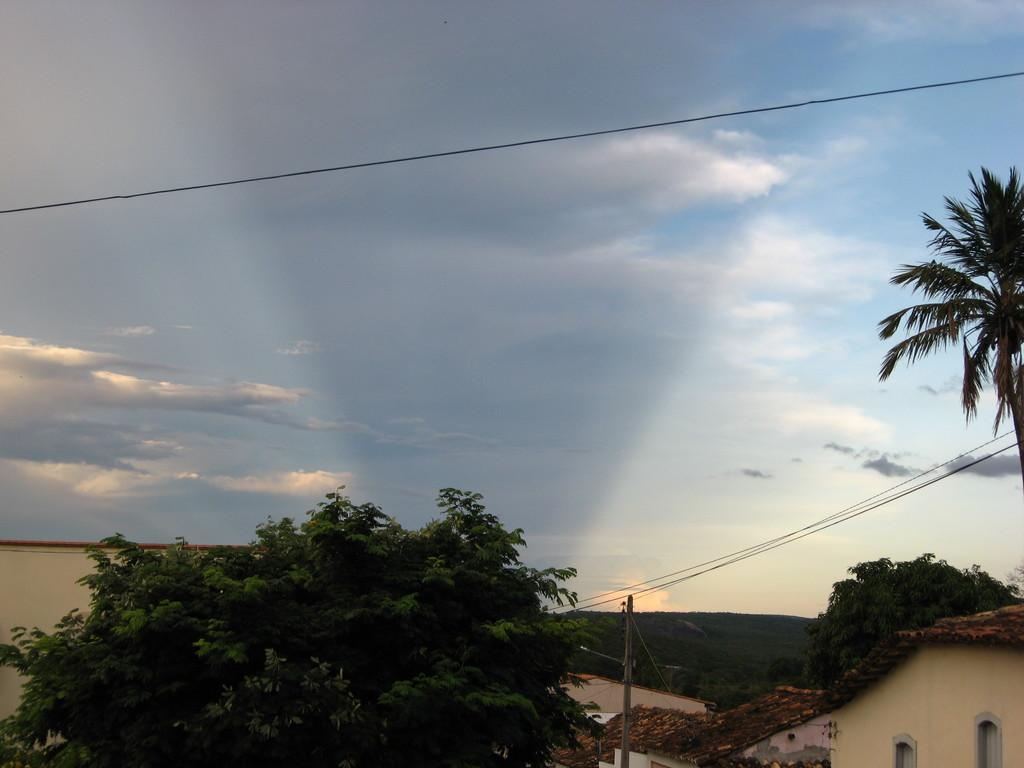What type of structures can be seen in the image? There are houses in the image. What other natural elements are present in the image? There are trees in the image. Are there any man-made objects related to electricity in the image? Yes, there is an electric pole and electric wires in the image. What type of geographical feature is visible in the image? There is a hill in the image. How would you describe the sky in the image? The sky is cloudy and pale blue in the image. How many bubbles can be seen floating around the electric pole in the image? There are no bubbles present in the image; it features houses, trees, an electric pole, electric wires, a hill, and a cloudy, pale blue sky. What type of beetle can be seen crawling on the hill in the image? There are no beetles present in the image; it only features houses, trees, an electric pole, electric wires, and a hill with a cloudy, pale blue sky. 